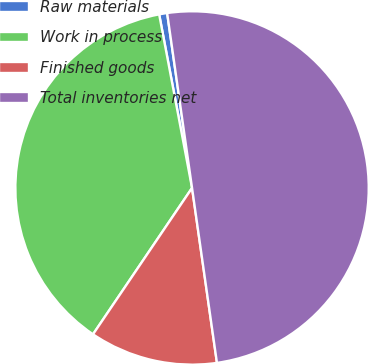<chart> <loc_0><loc_0><loc_500><loc_500><pie_chart><fcel>Raw materials<fcel>Work in process<fcel>Finished goods<fcel>Total inventories net<nl><fcel>0.73%<fcel>37.55%<fcel>11.72%<fcel>50.0%<nl></chart> 